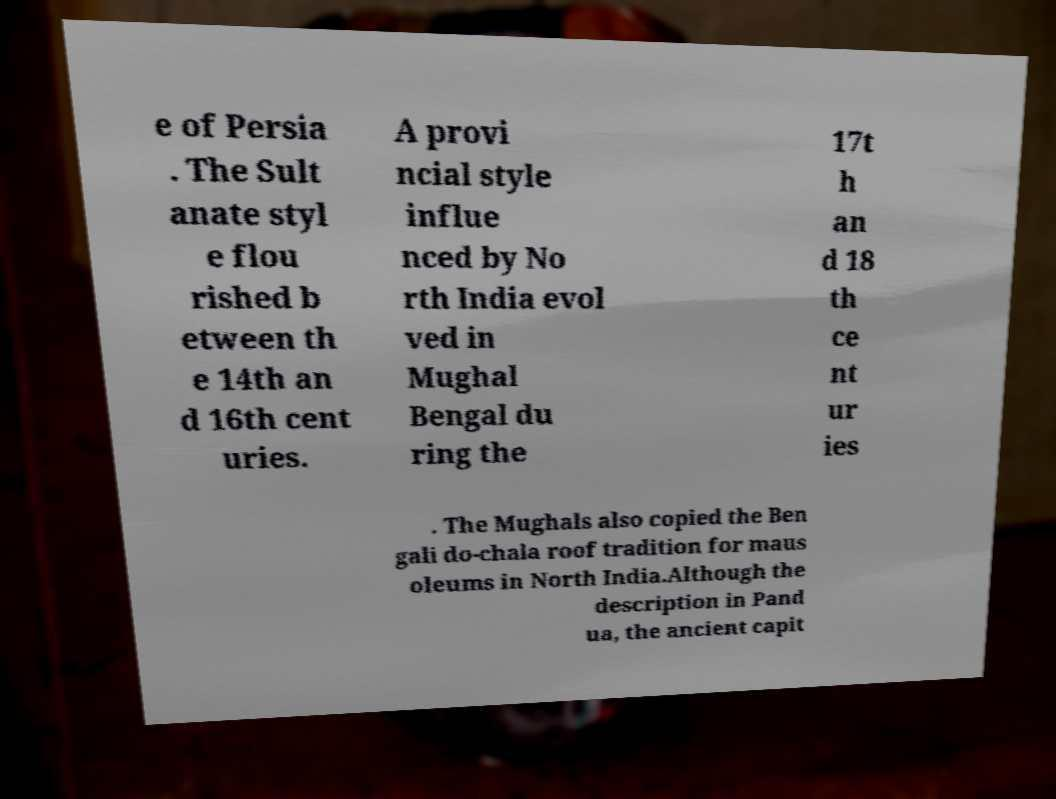Can you read and provide the text displayed in the image?This photo seems to have some interesting text. Can you extract and type it out for me? e of Persia . The Sult anate styl e flou rished b etween th e 14th an d 16th cent uries. A provi ncial style influe nced by No rth India evol ved in Mughal Bengal du ring the 17t h an d 18 th ce nt ur ies . The Mughals also copied the Ben gali do-chala roof tradition for maus oleums in North India.Although the description in Pand ua, the ancient capit 